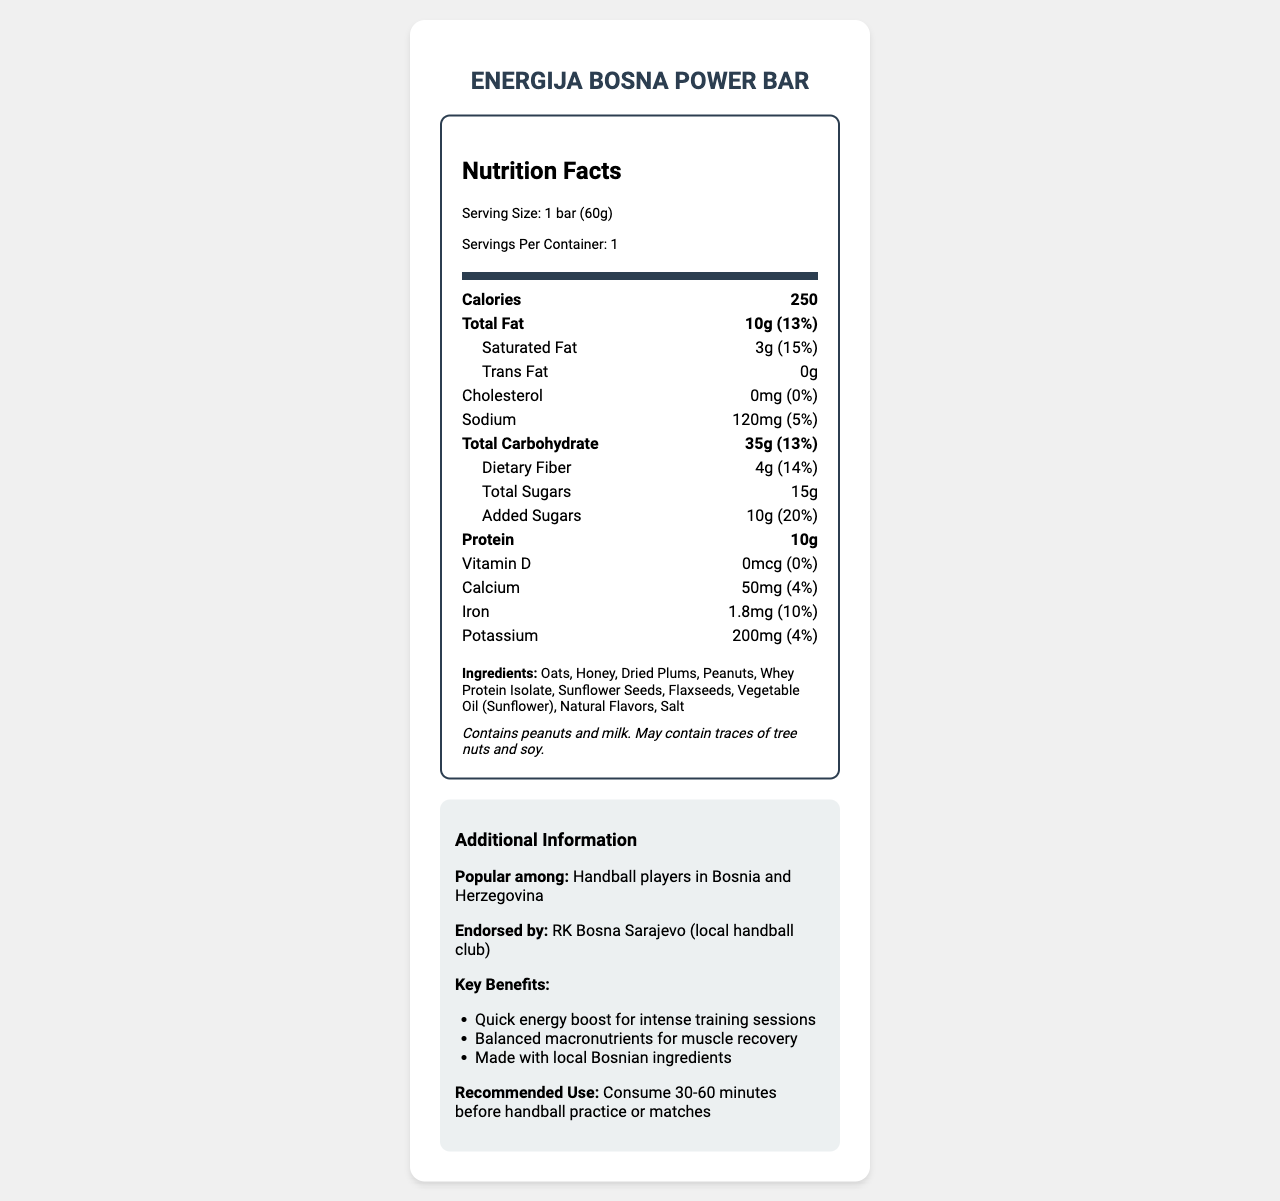what is the serving size of the Energija Bosna Power Bar? The serving size is mentioned in the nutrition facts section as "Serving Size: 1 bar (60g)."
Answer: 1 bar (60g) how many grams of protein are in one bar? Under the bolded "Protein" section in the nutrition facts, it is listed as 10g.
Answer: 10g what percentage of the daily value for saturated fat does one bar provide? The daily value percentage for saturated fat is stated as "(15%)" next to the amount of 3g.
Answer: 15% how much sodium does the bar contain? Sodium is listed separately in the nutrition facts with an amount of 120mg.
Answer: 120mg what are the main ingredients of this energy bar? The ingredients are listed at the bottom of the nutrition facts label.
Answer: Oats, Honey, Dried Plums, Peanuts, Whey Protein Isolate, Sunflower Seeds, Flaxseeds, Vegetable Oil (Sunflower), Natural Flavors, Salt how many total calories are in one serving of Energija Bosna Power Bar? The number of calories per serving is listed prominently under the "Calories" section in the nutrition facts.
Answer: 250 which local handball club endorses this energy bar? In the additional information, it states "Endorsed by: RK Bosna Sarajevo (local handball club)."
Answer: RK Bosna Sarajevo how much iron does this energy bar provide in terms of daily value percentage? The amount of iron is labeled with a daily value of "(10%)".
Answer: 10% what is the recommended time for consuming this energy bar before practice or matches? The recommended use states, "Consume 30-60 minutes before handball practice or matches."
Answer: 30-60 minutes which of the following nutrients has the highest daily value percentage in the Energija Bosna Power Bar? A. Total Fat B. Dietary Fiber C. Added Sugars D. Calcium Added Sugars have the highest daily value percentage of 20%, compared to Total Fat (13%), Dietary Fiber (14%), and Calcium (4%).
Answer: C. Added Sugars how much total carbohydrate does one bar contain? The total carbohydrate content is listed as 35g in the nutrition facts.
Answer: 35g does the Energija Bosna Power Bar contain any trans fat? The amount for trans fat is listed as 0g, meaning it contains no trans fat.
Answer: No is the Energija Bosna Power Bar a good source of Vitamin D? The amount of Vitamin D is 0mcg with a daily value of 0%, indicating it is not a good source of Vitamin D.
Answer: No describe the main purpose and benefits of the Energija Bosna Power Bar for handball players. This information is gathered from the additional information section, which highlights the bar's popularity, endorsements, key benefits, and recommendations for use.
Answer: The Energija Bosna Power Bar serves as a quick energy boost for intense training sessions, provides balanced macronutrients for muscle recovery, and is made with local Bosnian ingredients. It is popular among handball players in Bosnia and Herzegovina and endorsed by the local handball club RK Bosna Sarajevo. The recommended use is to consume it 30-60 minutes before handball practice or matches. where is the Energija Bosna Power Bar manufactured? The manufacturer is listed as "Zdravo Hrana d.o.o., Sarajevo" in the document.
Answer: Sarajevo how much total fat is in the Energija Bosna Power Bar? The total fat content is listed as 10g in the nutrition facts.
Answer: 10g can the document tell us the price of one Energija Bosna Power Bar? There is no information regarding the price of the energy bar in the document.
Answer: No 